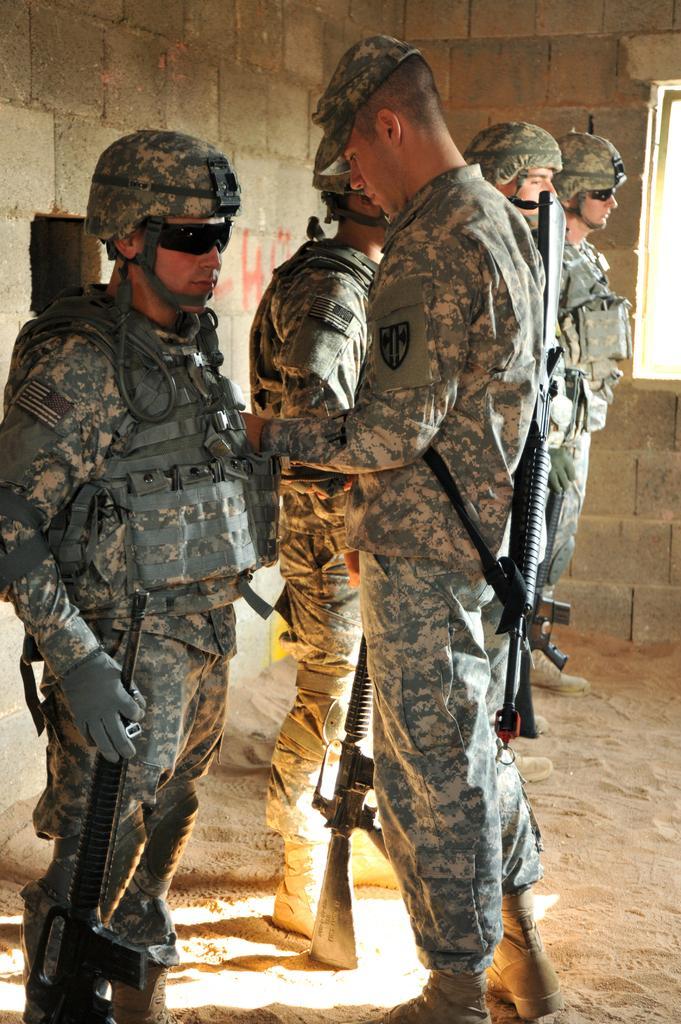In one or two sentences, can you explain what this image depicts? In this picture there is a person wearing military dress is standing and holding a gun in his hands and there is another person standing in front of him and there are three persons standing beside them and there is a brick wall in the background. 